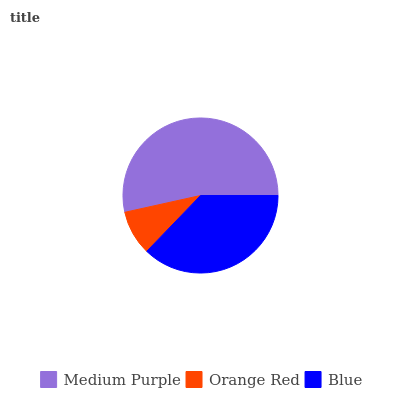Is Orange Red the minimum?
Answer yes or no. Yes. Is Medium Purple the maximum?
Answer yes or no. Yes. Is Blue the minimum?
Answer yes or no. No. Is Blue the maximum?
Answer yes or no. No. Is Blue greater than Orange Red?
Answer yes or no. Yes. Is Orange Red less than Blue?
Answer yes or no. Yes. Is Orange Red greater than Blue?
Answer yes or no. No. Is Blue less than Orange Red?
Answer yes or no. No. Is Blue the high median?
Answer yes or no. Yes. Is Blue the low median?
Answer yes or no. Yes. Is Medium Purple the high median?
Answer yes or no. No. Is Orange Red the low median?
Answer yes or no. No. 